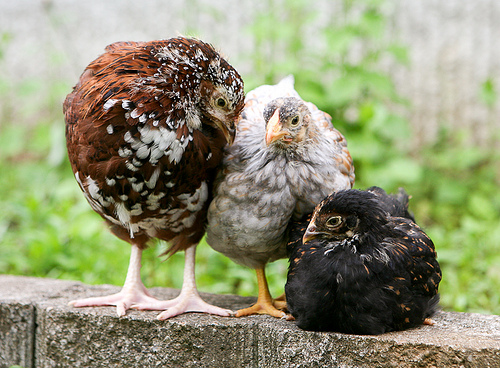<image>
Can you confirm if the black chicken is to the left of the brown chicken? Yes. From this viewpoint, the black chicken is positioned to the left side relative to the brown chicken. Is the bird behind the bird? No. The bird is not behind the bird. From this viewpoint, the bird appears to be positioned elsewhere in the scene. Where is the wall in relation to the chicken? Is it behind the chicken? No. The wall is not behind the chicken. From this viewpoint, the wall appears to be positioned elsewhere in the scene. Where is the brown chic in relation to the black chic? Is it to the right of the black chic? No. The brown chic is not to the right of the black chic. The horizontal positioning shows a different relationship. 